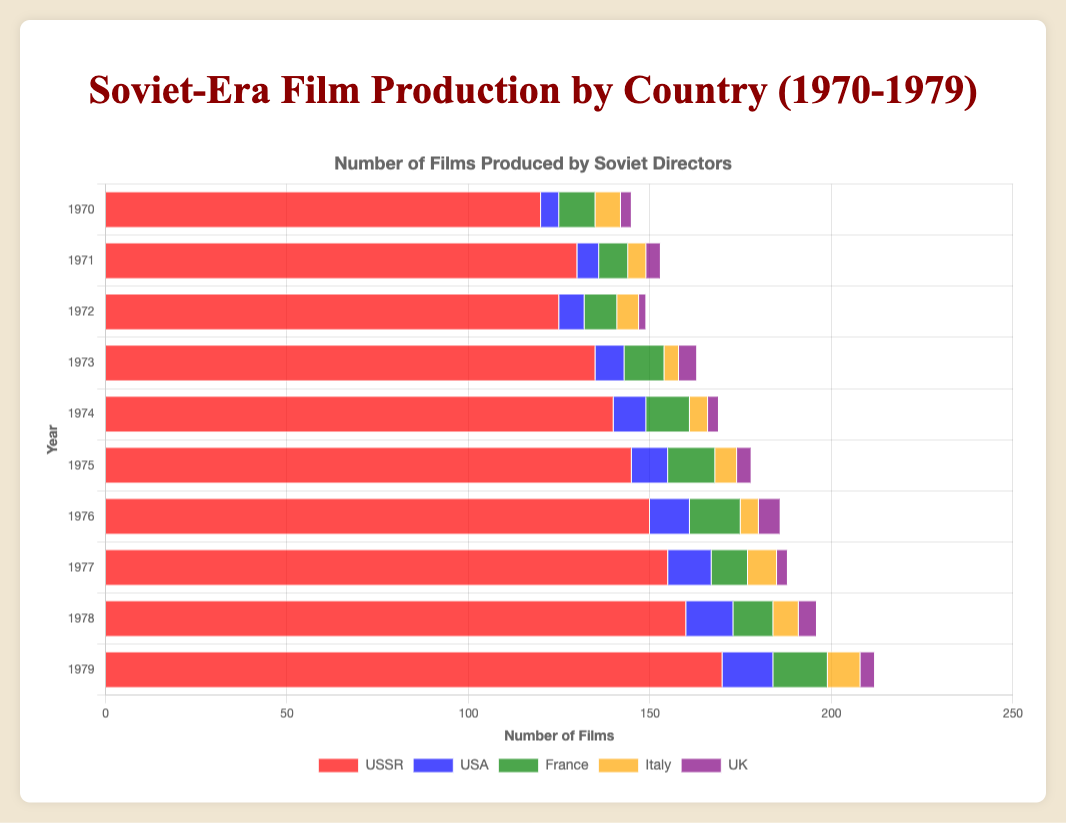Which year saw the highest number of films produced by Soviet directors in the USSR? By examining the heights of the bars for each year under the USSR label, the tallest bar corresponds to the year 1979.
Answer: 1979 How many more films were produced in the USSR compared to the USA in 1975? The height of the bar for the USSR in 1975 is 145, and for the USA it is 10. The difference is 145 - 10.
Answer: 135 What is the average number of films produced by Soviet directors in France from 1970 to 1979? Sum the number of films produced each year in France: 10, 8, 9, 11, 12, 13, 14, 10, 11, 15. The total is 113. Divide by 10 (the number of years) to get the average.
Answer: 11.3 In which year did Italy see its highest number of Soviet-directed films, and what was the count? The tallest bar for Italy represents the year 1979 with 9 films.
Answer: 1979, 9 Which two countries had an equal number of Soviet-directed films in any given year, and what was the count? In 1970, France and Italy both had 7 films produced by Soviet directors.
Answer: France and Italy, 7 How did the number of films produced by Soviet directors in the UK change from 1970 to 1979? Refer to the bar heights for the UK from 1970 to 1979; they are 3, 4, 2, 5, 3, 4, 6, 3, 5, 4. There were variations but an overall increase followed by fluctuations.
Answer: Varied, with fluctuations By how much did the production of Soviet-directed films in the USA increase from 1970 to 1979? The bar for the USA in 1970 is 5, and in 1979 it is 14. The increase is 14 - 5.
Answer: 9 Which country had the most inconsistent production of Soviet-directed films over the decade? France's bars show significant fluctuations over the years with values 10, 8, 9, 11, 12, 13, 14, 10, 11, 15.
Answer: France Summarize the trend of Soviet-directed films production in the USSR from 1970 to 1979. The trend for the USSR shows a continuous increase with minor fluctuations in some years but an overall upward trajectory from 120 films in 1970 to 170 films in 1979.
Answer: Increasing trend 